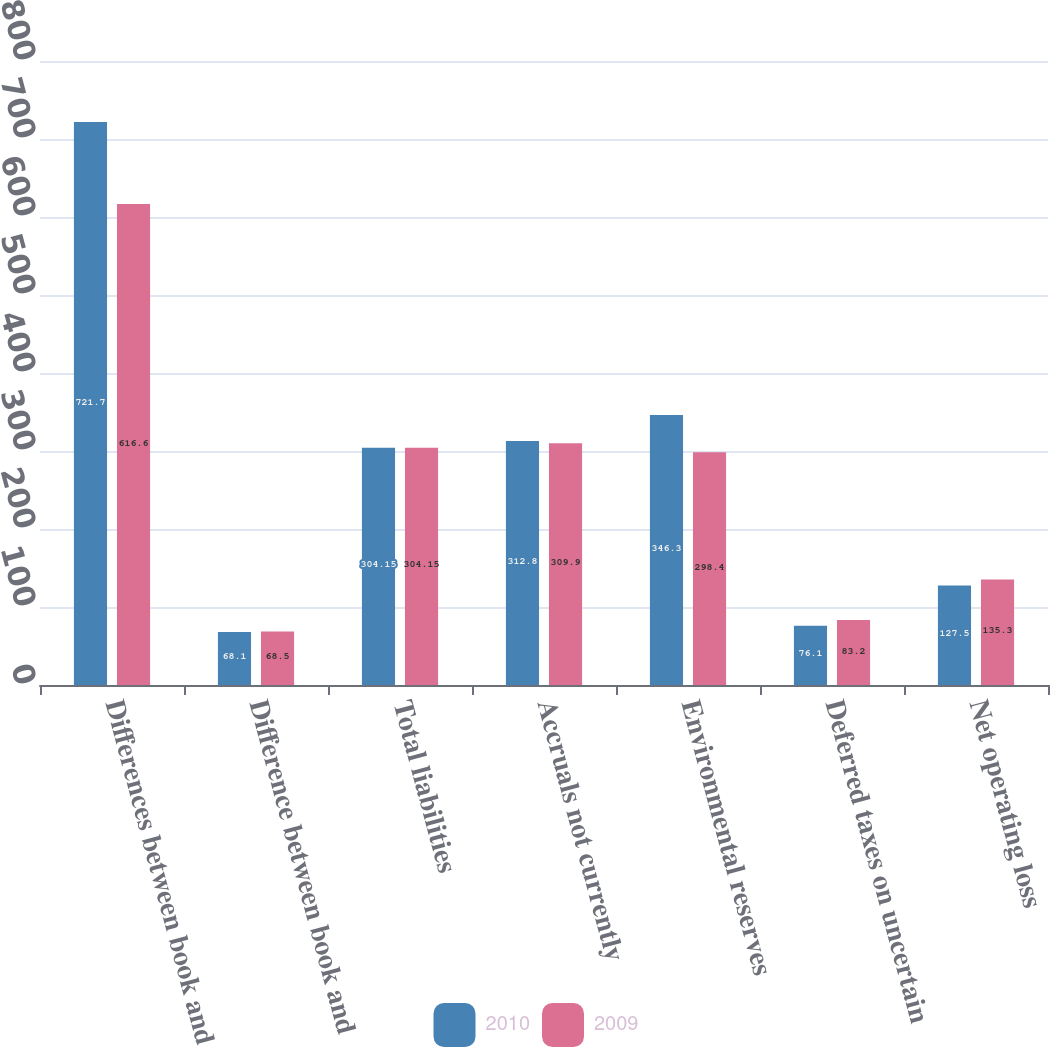Convert chart to OTSL. <chart><loc_0><loc_0><loc_500><loc_500><stacked_bar_chart><ecel><fcel>Differences between book and<fcel>Difference between book and<fcel>Total liabilities<fcel>Accruals not currently<fcel>Environmental reserves<fcel>Deferred taxes on uncertain<fcel>Net operating loss<nl><fcel>2010<fcel>721.7<fcel>68.1<fcel>304.15<fcel>312.8<fcel>346.3<fcel>76.1<fcel>127.5<nl><fcel>2009<fcel>616.6<fcel>68.5<fcel>304.15<fcel>309.9<fcel>298.4<fcel>83.2<fcel>135.3<nl></chart> 